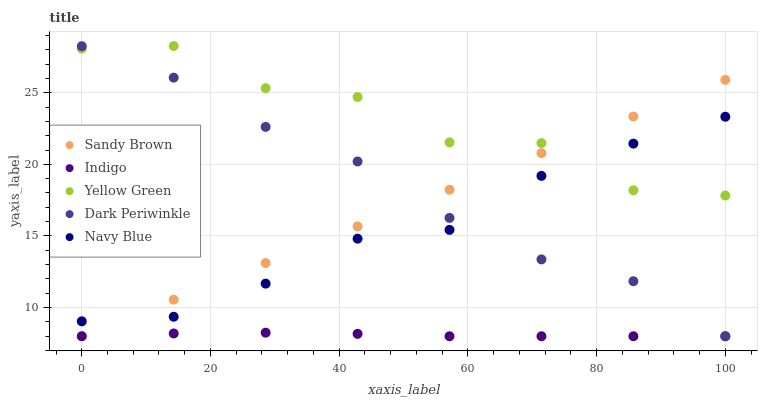Does Indigo have the minimum area under the curve?
Answer yes or no. Yes. Does Yellow Green have the maximum area under the curve?
Answer yes or no. Yes. Does Navy Blue have the minimum area under the curve?
Answer yes or no. No. Does Navy Blue have the maximum area under the curve?
Answer yes or no. No. Is Sandy Brown the smoothest?
Answer yes or no. Yes. Is Yellow Green the roughest?
Answer yes or no. Yes. Is Navy Blue the smoothest?
Answer yes or no. No. Is Navy Blue the roughest?
Answer yes or no. No. Does Indigo have the lowest value?
Answer yes or no. Yes. Does Navy Blue have the lowest value?
Answer yes or no. No. Does Yellow Green have the highest value?
Answer yes or no. Yes. Does Navy Blue have the highest value?
Answer yes or no. No. Is Indigo less than Navy Blue?
Answer yes or no. Yes. Is Navy Blue greater than Indigo?
Answer yes or no. Yes. Does Dark Periwinkle intersect Indigo?
Answer yes or no. Yes. Is Dark Periwinkle less than Indigo?
Answer yes or no. No. Is Dark Periwinkle greater than Indigo?
Answer yes or no. No. Does Indigo intersect Navy Blue?
Answer yes or no. No. 